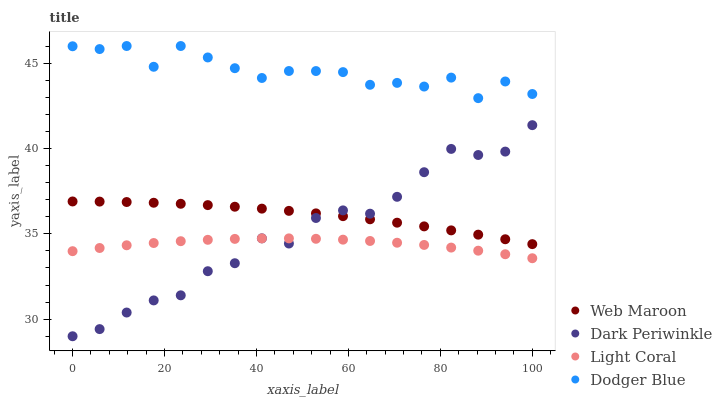Does Light Coral have the minimum area under the curve?
Answer yes or no. Yes. Does Dodger Blue have the maximum area under the curve?
Answer yes or no. Yes. Does Web Maroon have the minimum area under the curve?
Answer yes or no. No. Does Web Maroon have the maximum area under the curve?
Answer yes or no. No. Is Web Maroon the smoothest?
Answer yes or no. Yes. Is Dodger Blue the roughest?
Answer yes or no. Yes. Is Dodger Blue the smoothest?
Answer yes or no. No. Is Web Maroon the roughest?
Answer yes or no. No. Does Dark Periwinkle have the lowest value?
Answer yes or no. Yes. Does Web Maroon have the lowest value?
Answer yes or no. No. Does Dodger Blue have the highest value?
Answer yes or no. Yes. Does Web Maroon have the highest value?
Answer yes or no. No. Is Light Coral less than Web Maroon?
Answer yes or no. Yes. Is Dodger Blue greater than Light Coral?
Answer yes or no. Yes. Does Dark Periwinkle intersect Light Coral?
Answer yes or no. Yes. Is Dark Periwinkle less than Light Coral?
Answer yes or no. No. Is Dark Periwinkle greater than Light Coral?
Answer yes or no. No. Does Light Coral intersect Web Maroon?
Answer yes or no. No. 